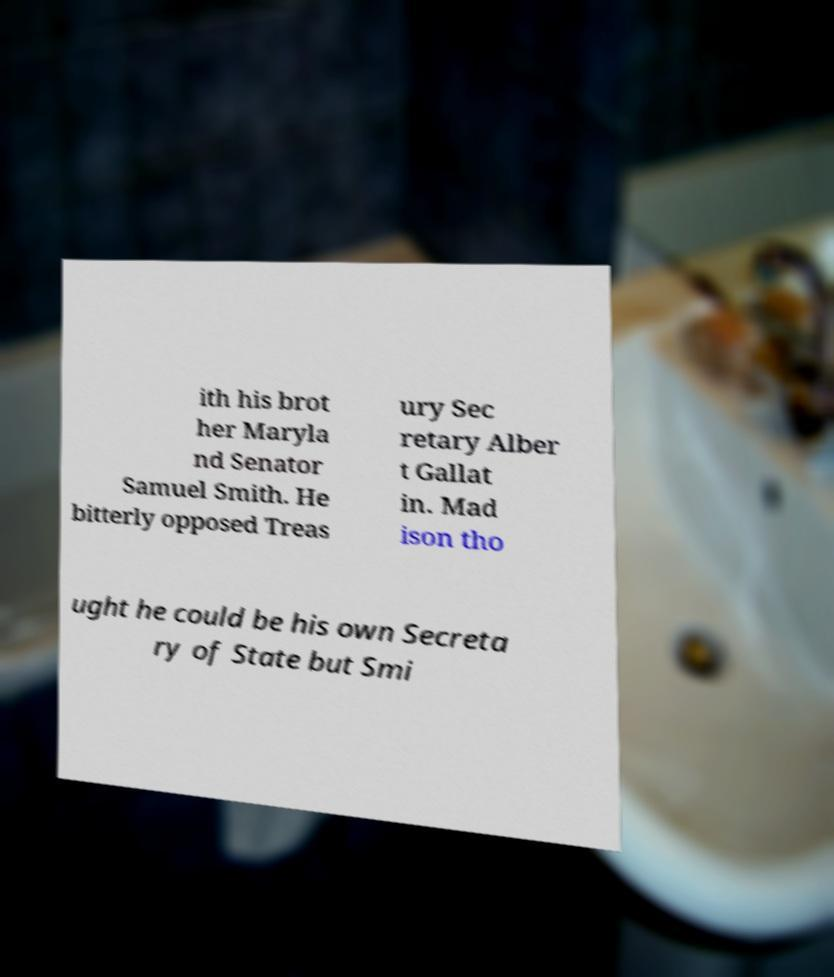There's text embedded in this image that I need extracted. Can you transcribe it verbatim? ith his brot her Maryla nd Senator Samuel Smith. He bitterly opposed Treas ury Sec retary Alber t Gallat in. Mad ison tho ught he could be his own Secreta ry of State but Smi 